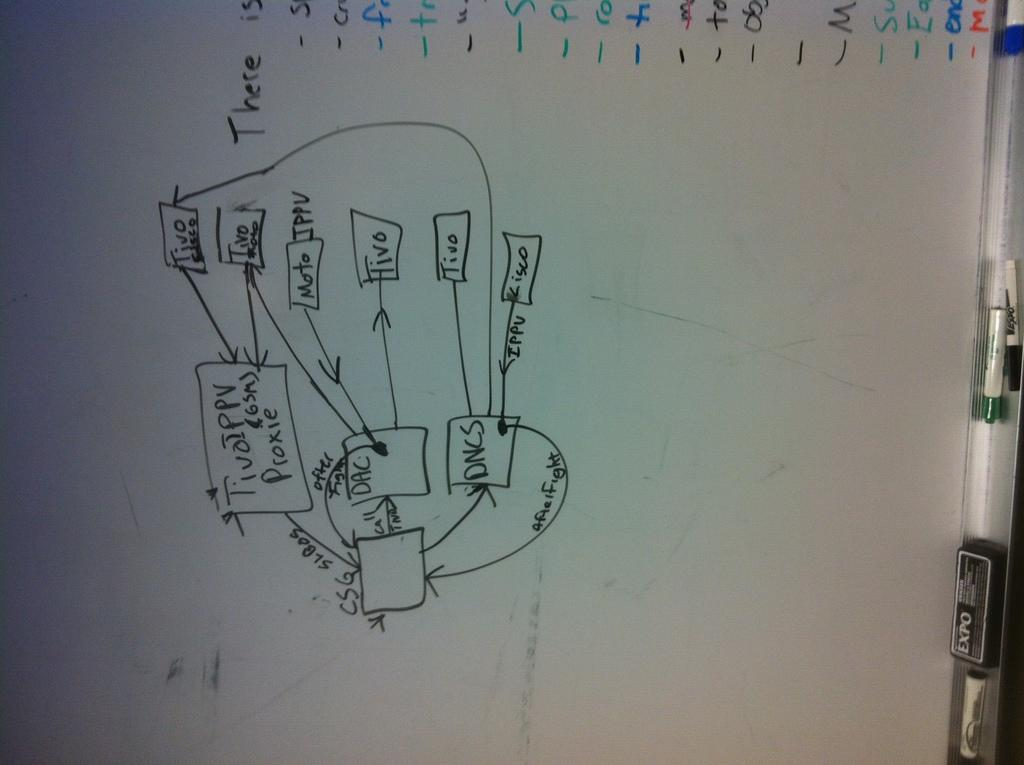<image>
Present a compact description of the photo's key features. the word tivo that is surrounded by a box 